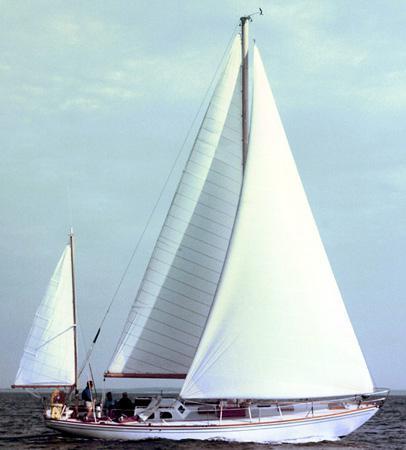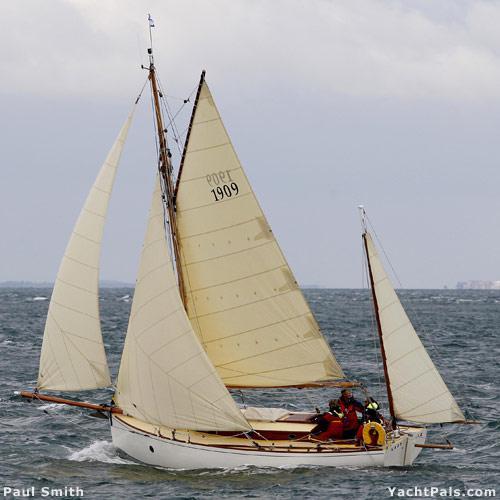The first image is the image on the left, the second image is the image on the right. Given the left and right images, does the statement "One boat has more than 3 sails" hold true? Answer yes or no. Yes. The first image is the image on the left, the second image is the image on the right. Given the left and right images, does the statement "the sailboat has no more than 3 sails" hold true? Answer yes or no. No. 